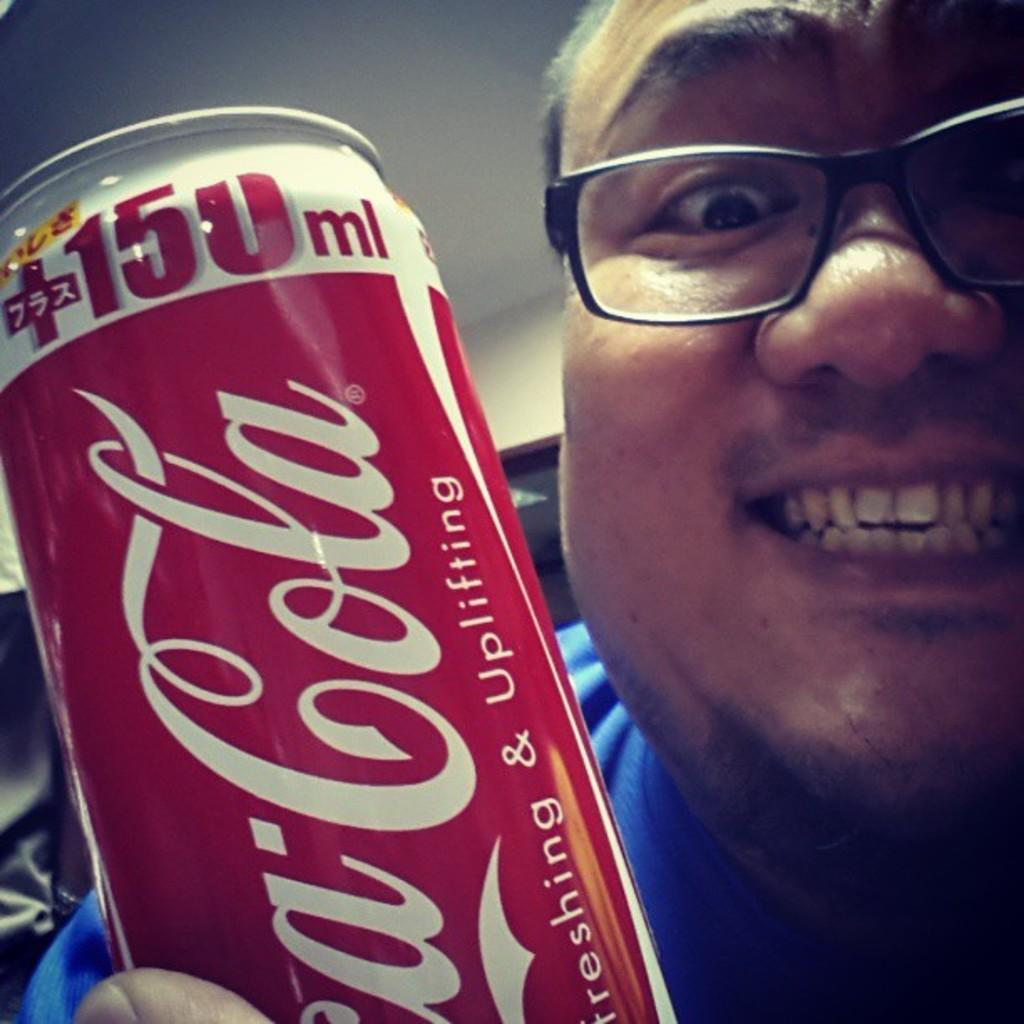Provide a one-sentence caption for the provided image. A guy with glasses on smiling holding a can of Coca-Cola 150ml that says refreshing and uplifting. 